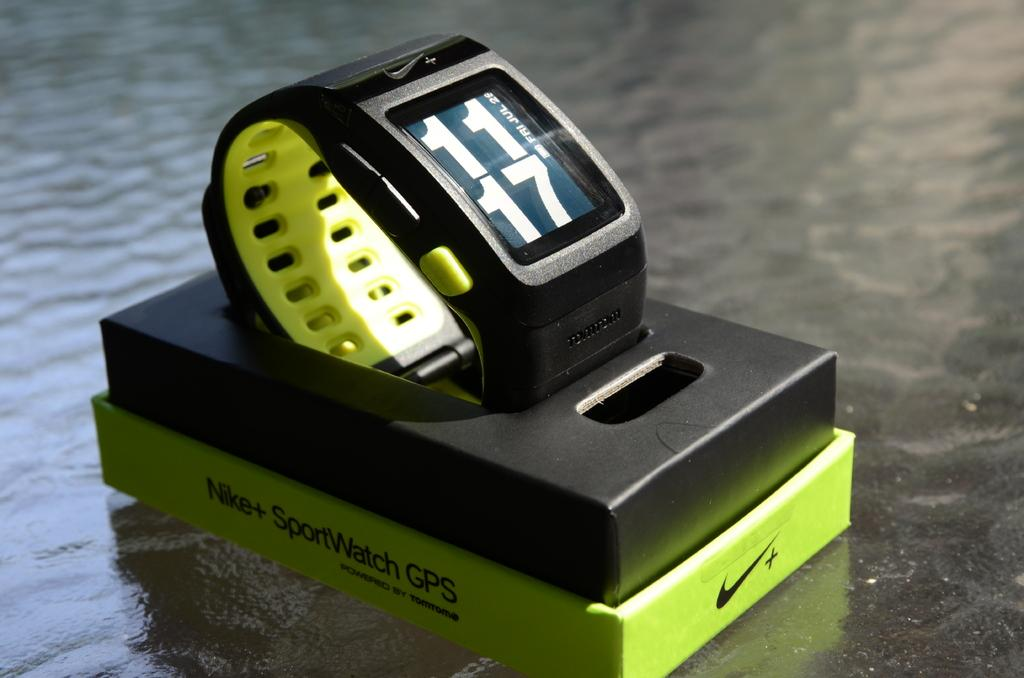<image>
Write a terse but informative summary of the picture. A Nike+ SportsWatch with GPS is sitting its open packaging. 